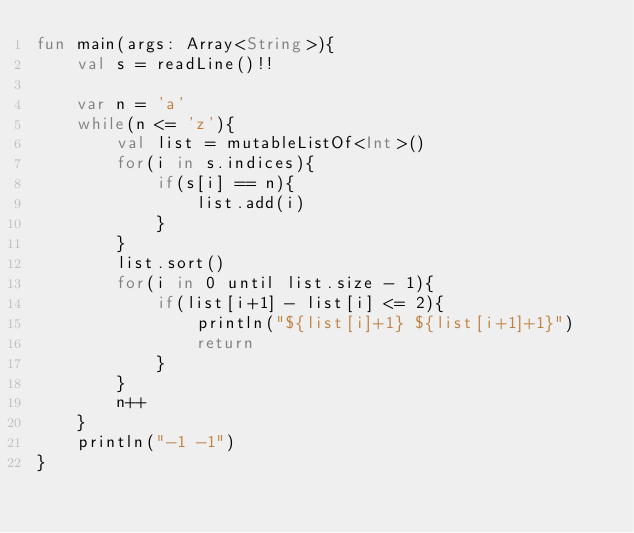<code> <loc_0><loc_0><loc_500><loc_500><_Kotlin_>fun main(args: Array<String>){
    val s = readLine()!!

    var n = 'a'
    while(n <= 'z'){
        val list = mutableListOf<Int>()
        for(i in s.indices){
            if(s[i] == n){
                list.add(i)
            }
        }
        list.sort()
        for(i in 0 until list.size - 1){
            if(list[i+1] - list[i] <= 2){
                println("${list[i]+1} ${list[i+1]+1}")
                return
            }
        }
        n++
    }
    println("-1 -1")
}</code> 